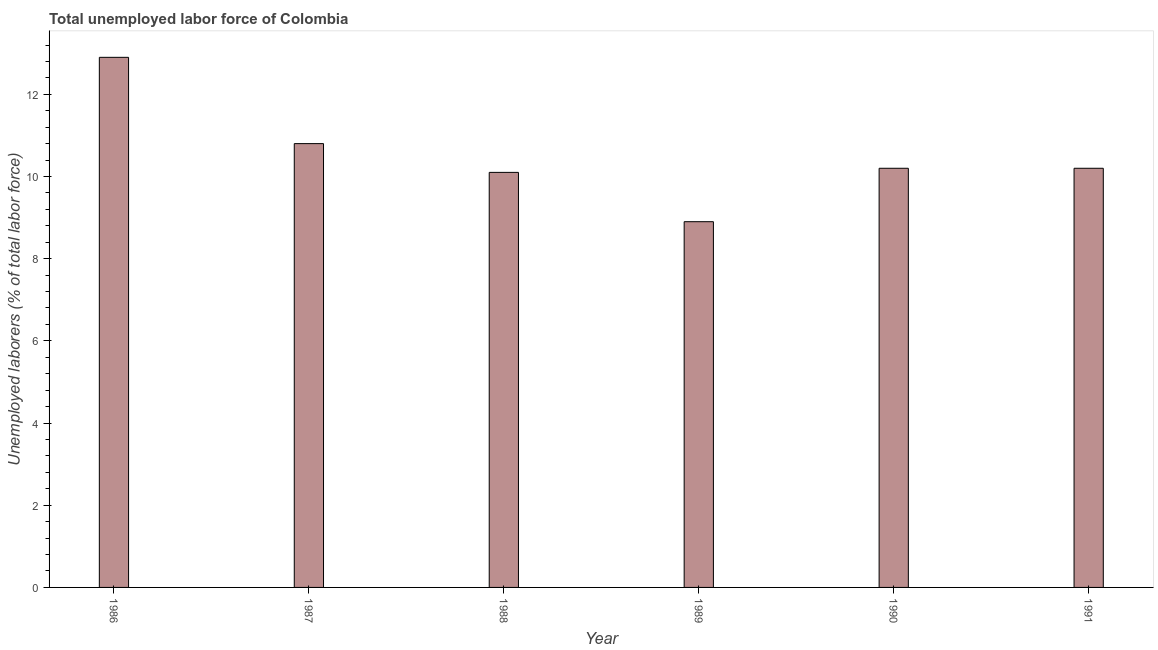Does the graph contain any zero values?
Offer a terse response. No. Does the graph contain grids?
Your answer should be very brief. No. What is the title of the graph?
Offer a terse response. Total unemployed labor force of Colombia. What is the label or title of the Y-axis?
Provide a succinct answer. Unemployed laborers (% of total labor force). What is the total unemployed labour force in 1986?
Offer a very short reply. 12.9. Across all years, what is the maximum total unemployed labour force?
Offer a very short reply. 12.9. Across all years, what is the minimum total unemployed labour force?
Your answer should be very brief. 8.9. In which year was the total unemployed labour force minimum?
Your answer should be compact. 1989. What is the sum of the total unemployed labour force?
Give a very brief answer. 63.1. What is the average total unemployed labour force per year?
Your answer should be compact. 10.52. What is the median total unemployed labour force?
Your answer should be very brief. 10.2. What is the ratio of the total unemployed labour force in 1987 to that in 1991?
Offer a terse response. 1.06. Is the total unemployed labour force in 1987 less than that in 1991?
Provide a short and direct response. No. Is the difference between the total unemployed labour force in 1986 and 1990 greater than the difference between any two years?
Your answer should be compact. No. What is the difference between the highest and the second highest total unemployed labour force?
Provide a succinct answer. 2.1. Is the sum of the total unemployed labour force in 1988 and 1990 greater than the maximum total unemployed labour force across all years?
Provide a succinct answer. Yes. In how many years, is the total unemployed labour force greater than the average total unemployed labour force taken over all years?
Offer a terse response. 2. How many bars are there?
Offer a terse response. 6. Are all the bars in the graph horizontal?
Provide a short and direct response. No. Are the values on the major ticks of Y-axis written in scientific E-notation?
Ensure brevity in your answer.  No. What is the Unemployed laborers (% of total labor force) in 1986?
Your response must be concise. 12.9. What is the Unemployed laborers (% of total labor force) in 1987?
Your answer should be compact. 10.8. What is the Unemployed laborers (% of total labor force) of 1988?
Your answer should be very brief. 10.1. What is the Unemployed laborers (% of total labor force) of 1989?
Give a very brief answer. 8.9. What is the Unemployed laborers (% of total labor force) of 1990?
Provide a short and direct response. 10.2. What is the Unemployed laborers (% of total labor force) in 1991?
Offer a very short reply. 10.2. What is the difference between the Unemployed laborers (% of total labor force) in 1986 and 1987?
Provide a short and direct response. 2.1. What is the difference between the Unemployed laborers (% of total labor force) in 1987 and 1988?
Provide a succinct answer. 0.7. What is the difference between the Unemployed laborers (% of total labor force) in 1987 and 1989?
Offer a very short reply. 1.9. What is the difference between the Unemployed laborers (% of total labor force) in 1987 and 1990?
Ensure brevity in your answer.  0.6. What is the difference between the Unemployed laborers (% of total labor force) in 1987 and 1991?
Your answer should be very brief. 0.6. What is the difference between the Unemployed laborers (% of total labor force) in 1988 and 1991?
Your answer should be very brief. -0.1. What is the difference between the Unemployed laborers (% of total labor force) in 1989 and 1990?
Your response must be concise. -1.3. What is the difference between the Unemployed laborers (% of total labor force) in 1990 and 1991?
Offer a terse response. 0. What is the ratio of the Unemployed laborers (% of total labor force) in 1986 to that in 1987?
Offer a very short reply. 1.19. What is the ratio of the Unemployed laborers (% of total labor force) in 1986 to that in 1988?
Offer a terse response. 1.28. What is the ratio of the Unemployed laborers (% of total labor force) in 1986 to that in 1989?
Your answer should be very brief. 1.45. What is the ratio of the Unemployed laborers (% of total labor force) in 1986 to that in 1990?
Offer a very short reply. 1.26. What is the ratio of the Unemployed laborers (% of total labor force) in 1986 to that in 1991?
Make the answer very short. 1.26. What is the ratio of the Unemployed laborers (% of total labor force) in 1987 to that in 1988?
Offer a very short reply. 1.07. What is the ratio of the Unemployed laborers (% of total labor force) in 1987 to that in 1989?
Keep it short and to the point. 1.21. What is the ratio of the Unemployed laborers (% of total labor force) in 1987 to that in 1990?
Your response must be concise. 1.06. What is the ratio of the Unemployed laborers (% of total labor force) in 1987 to that in 1991?
Provide a succinct answer. 1.06. What is the ratio of the Unemployed laborers (% of total labor force) in 1988 to that in 1989?
Give a very brief answer. 1.14. What is the ratio of the Unemployed laborers (% of total labor force) in 1988 to that in 1990?
Offer a terse response. 0.99. What is the ratio of the Unemployed laborers (% of total labor force) in 1989 to that in 1990?
Your answer should be very brief. 0.87. What is the ratio of the Unemployed laborers (% of total labor force) in 1989 to that in 1991?
Your answer should be very brief. 0.87. What is the ratio of the Unemployed laborers (% of total labor force) in 1990 to that in 1991?
Provide a short and direct response. 1. 